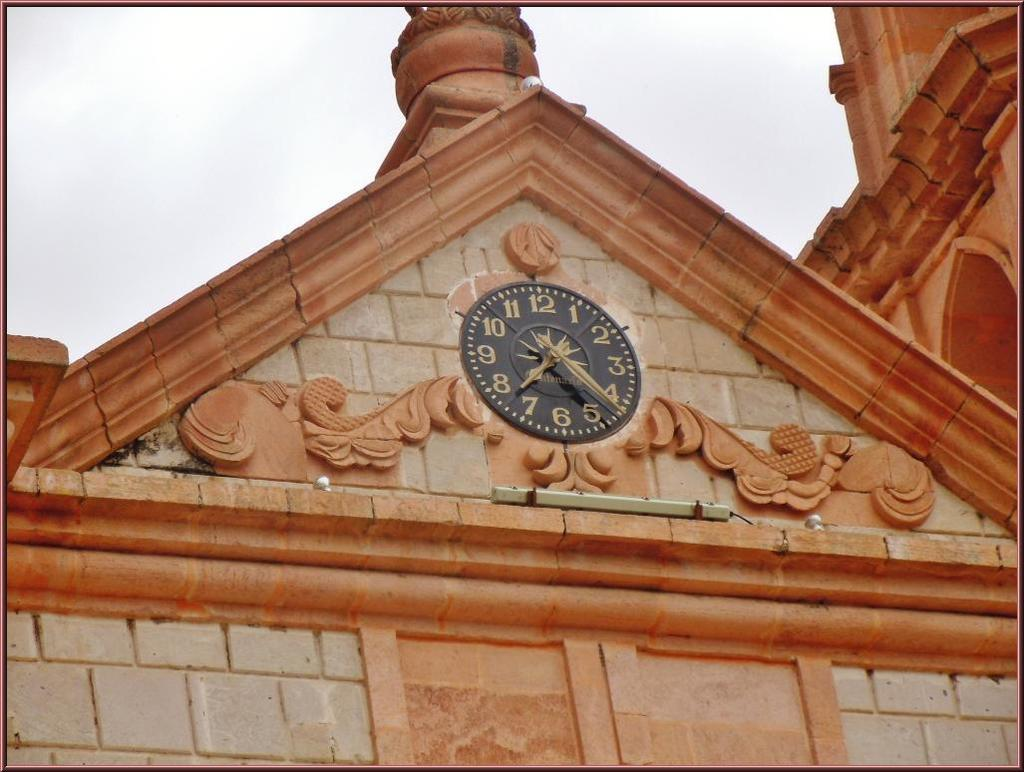<image>
Relay a brief, clear account of the picture shown. a closeup of an analog clock with numbers 1-12 on a brick building 